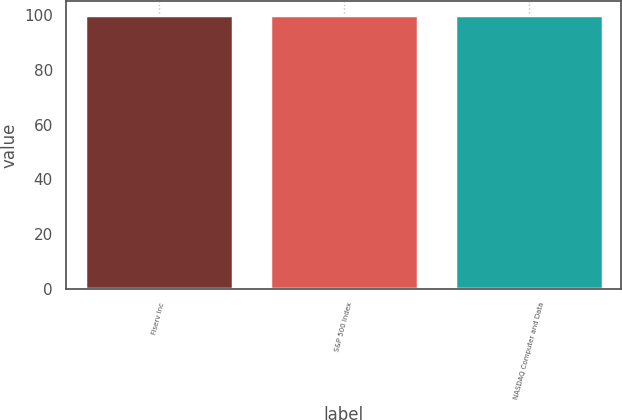<chart> <loc_0><loc_0><loc_500><loc_500><bar_chart><fcel>Fiserv Inc<fcel>S&P 500 Index<fcel>NASDAQ Computer and Data<nl><fcel>100<fcel>100.1<fcel>100.2<nl></chart> 